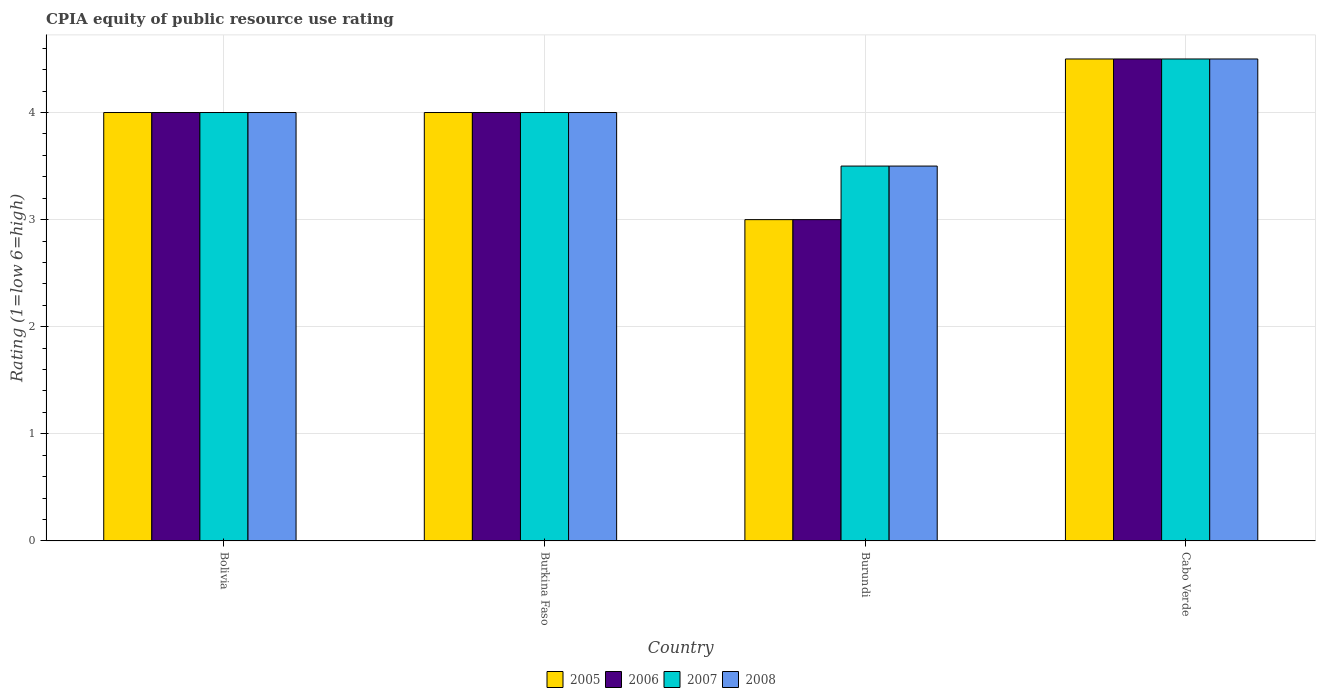How many groups of bars are there?
Offer a terse response. 4. Are the number of bars per tick equal to the number of legend labels?
Your response must be concise. Yes. Are the number of bars on each tick of the X-axis equal?
Keep it short and to the point. Yes. How many bars are there on the 2nd tick from the left?
Provide a succinct answer. 4. How many bars are there on the 2nd tick from the right?
Offer a terse response. 4. What is the label of the 1st group of bars from the left?
Ensure brevity in your answer.  Bolivia. What is the CPIA rating in 2007 in Bolivia?
Ensure brevity in your answer.  4. Across all countries, what is the maximum CPIA rating in 2007?
Your answer should be compact. 4.5. Across all countries, what is the minimum CPIA rating in 2007?
Your response must be concise. 3.5. In which country was the CPIA rating in 2006 maximum?
Offer a terse response. Cabo Verde. In which country was the CPIA rating in 2006 minimum?
Give a very brief answer. Burundi. What is the average CPIA rating in 2005 per country?
Your answer should be compact. 3.88. What is the ratio of the CPIA rating in 2006 in Burkina Faso to that in Cabo Verde?
Keep it short and to the point. 0.89. Is the CPIA rating in 2008 in Bolivia less than that in Cabo Verde?
Keep it short and to the point. Yes. What is the difference between the highest and the second highest CPIA rating in 2007?
Your response must be concise. 0.5. Is the sum of the CPIA rating in 2005 in Burkina Faso and Cabo Verde greater than the maximum CPIA rating in 2008 across all countries?
Your answer should be compact. Yes. Is it the case that in every country, the sum of the CPIA rating in 2005 and CPIA rating in 2007 is greater than the sum of CPIA rating in 2006 and CPIA rating in 2008?
Offer a very short reply. No. What does the 1st bar from the left in Burkina Faso represents?
Your response must be concise. 2005. Are all the bars in the graph horizontal?
Offer a very short reply. No. How many countries are there in the graph?
Your answer should be compact. 4. Does the graph contain any zero values?
Provide a succinct answer. No. Does the graph contain grids?
Ensure brevity in your answer.  Yes. Where does the legend appear in the graph?
Offer a very short reply. Bottom center. How are the legend labels stacked?
Provide a short and direct response. Horizontal. What is the title of the graph?
Ensure brevity in your answer.  CPIA equity of public resource use rating. What is the label or title of the X-axis?
Your response must be concise. Country. What is the Rating (1=low 6=high) of 2005 in Bolivia?
Your response must be concise. 4. What is the Rating (1=low 6=high) in 2007 in Bolivia?
Your answer should be compact. 4. What is the Rating (1=low 6=high) of 2007 in Burundi?
Your answer should be very brief. 3.5. What is the Rating (1=low 6=high) in 2006 in Cabo Verde?
Keep it short and to the point. 4.5. What is the Rating (1=low 6=high) in 2007 in Cabo Verde?
Provide a short and direct response. 4.5. Across all countries, what is the maximum Rating (1=low 6=high) in 2005?
Your answer should be compact. 4.5. Across all countries, what is the maximum Rating (1=low 6=high) in 2007?
Make the answer very short. 4.5. Across all countries, what is the minimum Rating (1=low 6=high) of 2008?
Give a very brief answer. 3.5. What is the total Rating (1=low 6=high) in 2006 in the graph?
Provide a succinct answer. 15.5. What is the difference between the Rating (1=low 6=high) in 2006 in Bolivia and that in Burkina Faso?
Provide a short and direct response. 0. What is the difference between the Rating (1=low 6=high) of 2007 in Bolivia and that in Burkina Faso?
Provide a succinct answer. 0. What is the difference between the Rating (1=low 6=high) of 2005 in Bolivia and that in Burundi?
Keep it short and to the point. 1. What is the difference between the Rating (1=low 6=high) in 2006 in Bolivia and that in Burundi?
Your answer should be very brief. 1. What is the difference between the Rating (1=low 6=high) of 2008 in Bolivia and that in Burundi?
Your answer should be very brief. 0.5. What is the difference between the Rating (1=low 6=high) in 2006 in Bolivia and that in Cabo Verde?
Ensure brevity in your answer.  -0.5. What is the difference between the Rating (1=low 6=high) in 2008 in Bolivia and that in Cabo Verde?
Give a very brief answer. -0.5. What is the difference between the Rating (1=low 6=high) in 2007 in Burkina Faso and that in Burundi?
Ensure brevity in your answer.  0.5. What is the difference between the Rating (1=low 6=high) in 2008 in Burkina Faso and that in Burundi?
Your response must be concise. 0.5. What is the difference between the Rating (1=low 6=high) of 2005 in Burkina Faso and that in Cabo Verde?
Ensure brevity in your answer.  -0.5. What is the difference between the Rating (1=low 6=high) in 2008 in Burkina Faso and that in Cabo Verde?
Ensure brevity in your answer.  -0.5. What is the difference between the Rating (1=low 6=high) of 2006 in Burundi and that in Cabo Verde?
Give a very brief answer. -1.5. What is the difference between the Rating (1=low 6=high) of 2007 in Burundi and that in Cabo Verde?
Ensure brevity in your answer.  -1. What is the difference between the Rating (1=low 6=high) in 2005 in Bolivia and the Rating (1=low 6=high) in 2008 in Burkina Faso?
Offer a very short reply. 0. What is the difference between the Rating (1=low 6=high) in 2006 in Bolivia and the Rating (1=low 6=high) in 2007 in Burkina Faso?
Offer a terse response. 0. What is the difference between the Rating (1=low 6=high) of 2006 in Bolivia and the Rating (1=low 6=high) of 2007 in Burundi?
Give a very brief answer. 0.5. What is the difference between the Rating (1=low 6=high) of 2006 in Bolivia and the Rating (1=low 6=high) of 2008 in Burundi?
Your answer should be very brief. 0.5. What is the difference between the Rating (1=low 6=high) in 2007 in Bolivia and the Rating (1=low 6=high) in 2008 in Burundi?
Provide a short and direct response. 0.5. What is the difference between the Rating (1=low 6=high) in 2005 in Bolivia and the Rating (1=low 6=high) in 2006 in Cabo Verde?
Offer a very short reply. -0.5. What is the difference between the Rating (1=low 6=high) of 2005 in Bolivia and the Rating (1=low 6=high) of 2007 in Cabo Verde?
Keep it short and to the point. -0.5. What is the difference between the Rating (1=low 6=high) of 2006 in Bolivia and the Rating (1=low 6=high) of 2007 in Cabo Verde?
Provide a short and direct response. -0.5. What is the difference between the Rating (1=low 6=high) of 2006 in Bolivia and the Rating (1=low 6=high) of 2008 in Cabo Verde?
Ensure brevity in your answer.  -0.5. What is the difference between the Rating (1=low 6=high) in 2005 in Burkina Faso and the Rating (1=low 6=high) in 2006 in Burundi?
Ensure brevity in your answer.  1. What is the difference between the Rating (1=low 6=high) of 2006 in Burkina Faso and the Rating (1=low 6=high) of 2007 in Burundi?
Your answer should be very brief. 0.5. What is the difference between the Rating (1=low 6=high) in 2005 in Burkina Faso and the Rating (1=low 6=high) in 2006 in Cabo Verde?
Give a very brief answer. -0.5. What is the difference between the Rating (1=low 6=high) in 2005 in Burkina Faso and the Rating (1=low 6=high) in 2008 in Cabo Verde?
Offer a very short reply. -0.5. What is the difference between the Rating (1=low 6=high) of 2006 in Burkina Faso and the Rating (1=low 6=high) of 2007 in Cabo Verde?
Offer a terse response. -0.5. What is the difference between the Rating (1=low 6=high) in 2006 in Burkina Faso and the Rating (1=low 6=high) in 2008 in Cabo Verde?
Provide a succinct answer. -0.5. What is the difference between the Rating (1=low 6=high) of 2007 in Burkina Faso and the Rating (1=low 6=high) of 2008 in Cabo Verde?
Provide a succinct answer. -0.5. What is the difference between the Rating (1=low 6=high) of 2005 in Burundi and the Rating (1=low 6=high) of 2006 in Cabo Verde?
Keep it short and to the point. -1.5. What is the difference between the Rating (1=low 6=high) of 2005 in Burundi and the Rating (1=low 6=high) of 2008 in Cabo Verde?
Ensure brevity in your answer.  -1.5. What is the difference between the Rating (1=low 6=high) of 2006 in Burundi and the Rating (1=low 6=high) of 2007 in Cabo Verde?
Your answer should be very brief. -1.5. What is the difference between the Rating (1=low 6=high) of 2006 in Burundi and the Rating (1=low 6=high) of 2008 in Cabo Verde?
Ensure brevity in your answer.  -1.5. What is the average Rating (1=low 6=high) of 2005 per country?
Ensure brevity in your answer.  3.88. What is the average Rating (1=low 6=high) of 2006 per country?
Your answer should be very brief. 3.88. What is the average Rating (1=low 6=high) in 2007 per country?
Offer a terse response. 4. What is the average Rating (1=low 6=high) in 2008 per country?
Give a very brief answer. 4. What is the difference between the Rating (1=low 6=high) in 2005 and Rating (1=low 6=high) in 2007 in Bolivia?
Keep it short and to the point. 0. What is the difference between the Rating (1=low 6=high) of 2006 and Rating (1=low 6=high) of 2008 in Bolivia?
Your response must be concise. 0. What is the difference between the Rating (1=low 6=high) of 2007 and Rating (1=low 6=high) of 2008 in Bolivia?
Offer a very short reply. 0. What is the difference between the Rating (1=low 6=high) in 2005 and Rating (1=low 6=high) in 2006 in Burkina Faso?
Your response must be concise. 0. What is the difference between the Rating (1=low 6=high) of 2005 and Rating (1=low 6=high) of 2007 in Burkina Faso?
Offer a very short reply. 0. What is the difference between the Rating (1=low 6=high) of 2005 and Rating (1=low 6=high) of 2008 in Burkina Faso?
Your response must be concise. 0. What is the difference between the Rating (1=low 6=high) of 2006 and Rating (1=low 6=high) of 2007 in Burkina Faso?
Provide a succinct answer. 0. What is the difference between the Rating (1=low 6=high) in 2005 and Rating (1=low 6=high) in 2008 in Burundi?
Provide a short and direct response. -0.5. What is the difference between the Rating (1=low 6=high) in 2006 and Rating (1=low 6=high) in 2007 in Burundi?
Your answer should be very brief. -0.5. What is the difference between the Rating (1=low 6=high) in 2006 and Rating (1=low 6=high) in 2008 in Burundi?
Offer a very short reply. -0.5. What is the difference between the Rating (1=low 6=high) of 2005 and Rating (1=low 6=high) of 2007 in Cabo Verde?
Keep it short and to the point. 0. What is the difference between the Rating (1=low 6=high) in 2006 and Rating (1=low 6=high) in 2008 in Cabo Verde?
Offer a very short reply. 0. What is the difference between the Rating (1=low 6=high) of 2007 and Rating (1=low 6=high) of 2008 in Cabo Verde?
Keep it short and to the point. 0. What is the ratio of the Rating (1=low 6=high) in 2005 in Bolivia to that in Burkina Faso?
Ensure brevity in your answer.  1. What is the ratio of the Rating (1=low 6=high) of 2007 in Bolivia to that in Burkina Faso?
Make the answer very short. 1. What is the ratio of the Rating (1=low 6=high) of 2008 in Bolivia to that in Burkina Faso?
Ensure brevity in your answer.  1. What is the ratio of the Rating (1=low 6=high) of 2005 in Bolivia to that in Cabo Verde?
Provide a short and direct response. 0.89. What is the ratio of the Rating (1=low 6=high) in 2007 in Bolivia to that in Cabo Verde?
Your response must be concise. 0.89. What is the ratio of the Rating (1=low 6=high) in 2008 in Bolivia to that in Cabo Verde?
Give a very brief answer. 0.89. What is the ratio of the Rating (1=low 6=high) of 2007 in Burkina Faso to that in Burundi?
Your response must be concise. 1.14. What is the ratio of the Rating (1=low 6=high) in 2008 in Burkina Faso to that in Burundi?
Offer a terse response. 1.14. What is the ratio of the Rating (1=low 6=high) of 2006 in Burkina Faso to that in Cabo Verde?
Provide a short and direct response. 0.89. What is the ratio of the Rating (1=low 6=high) in 2005 in Burundi to that in Cabo Verde?
Your answer should be very brief. 0.67. What is the ratio of the Rating (1=low 6=high) in 2006 in Burundi to that in Cabo Verde?
Make the answer very short. 0.67. What is the ratio of the Rating (1=low 6=high) in 2008 in Burundi to that in Cabo Verde?
Provide a succinct answer. 0.78. What is the difference between the highest and the second highest Rating (1=low 6=high) in 2006?
Your answer should be compact. 0.5. What is the difference between the highest and the second highest Rating (1=low 6=high) of 2008?
Make the answer very short. 0.5. What is the difference between the highest and the lowest Rating (1=low 6=high) in 2005?
Your response must be concise. 1.5. What is the difference between the highest and the lowest Rating (1=low 6=high) in 2006?
Provide a succinct answer. 1.5. What is the difference between the highest and the lowest Rating (1=low 6=high) in 2007?
Provide a short and direct response. 1. 